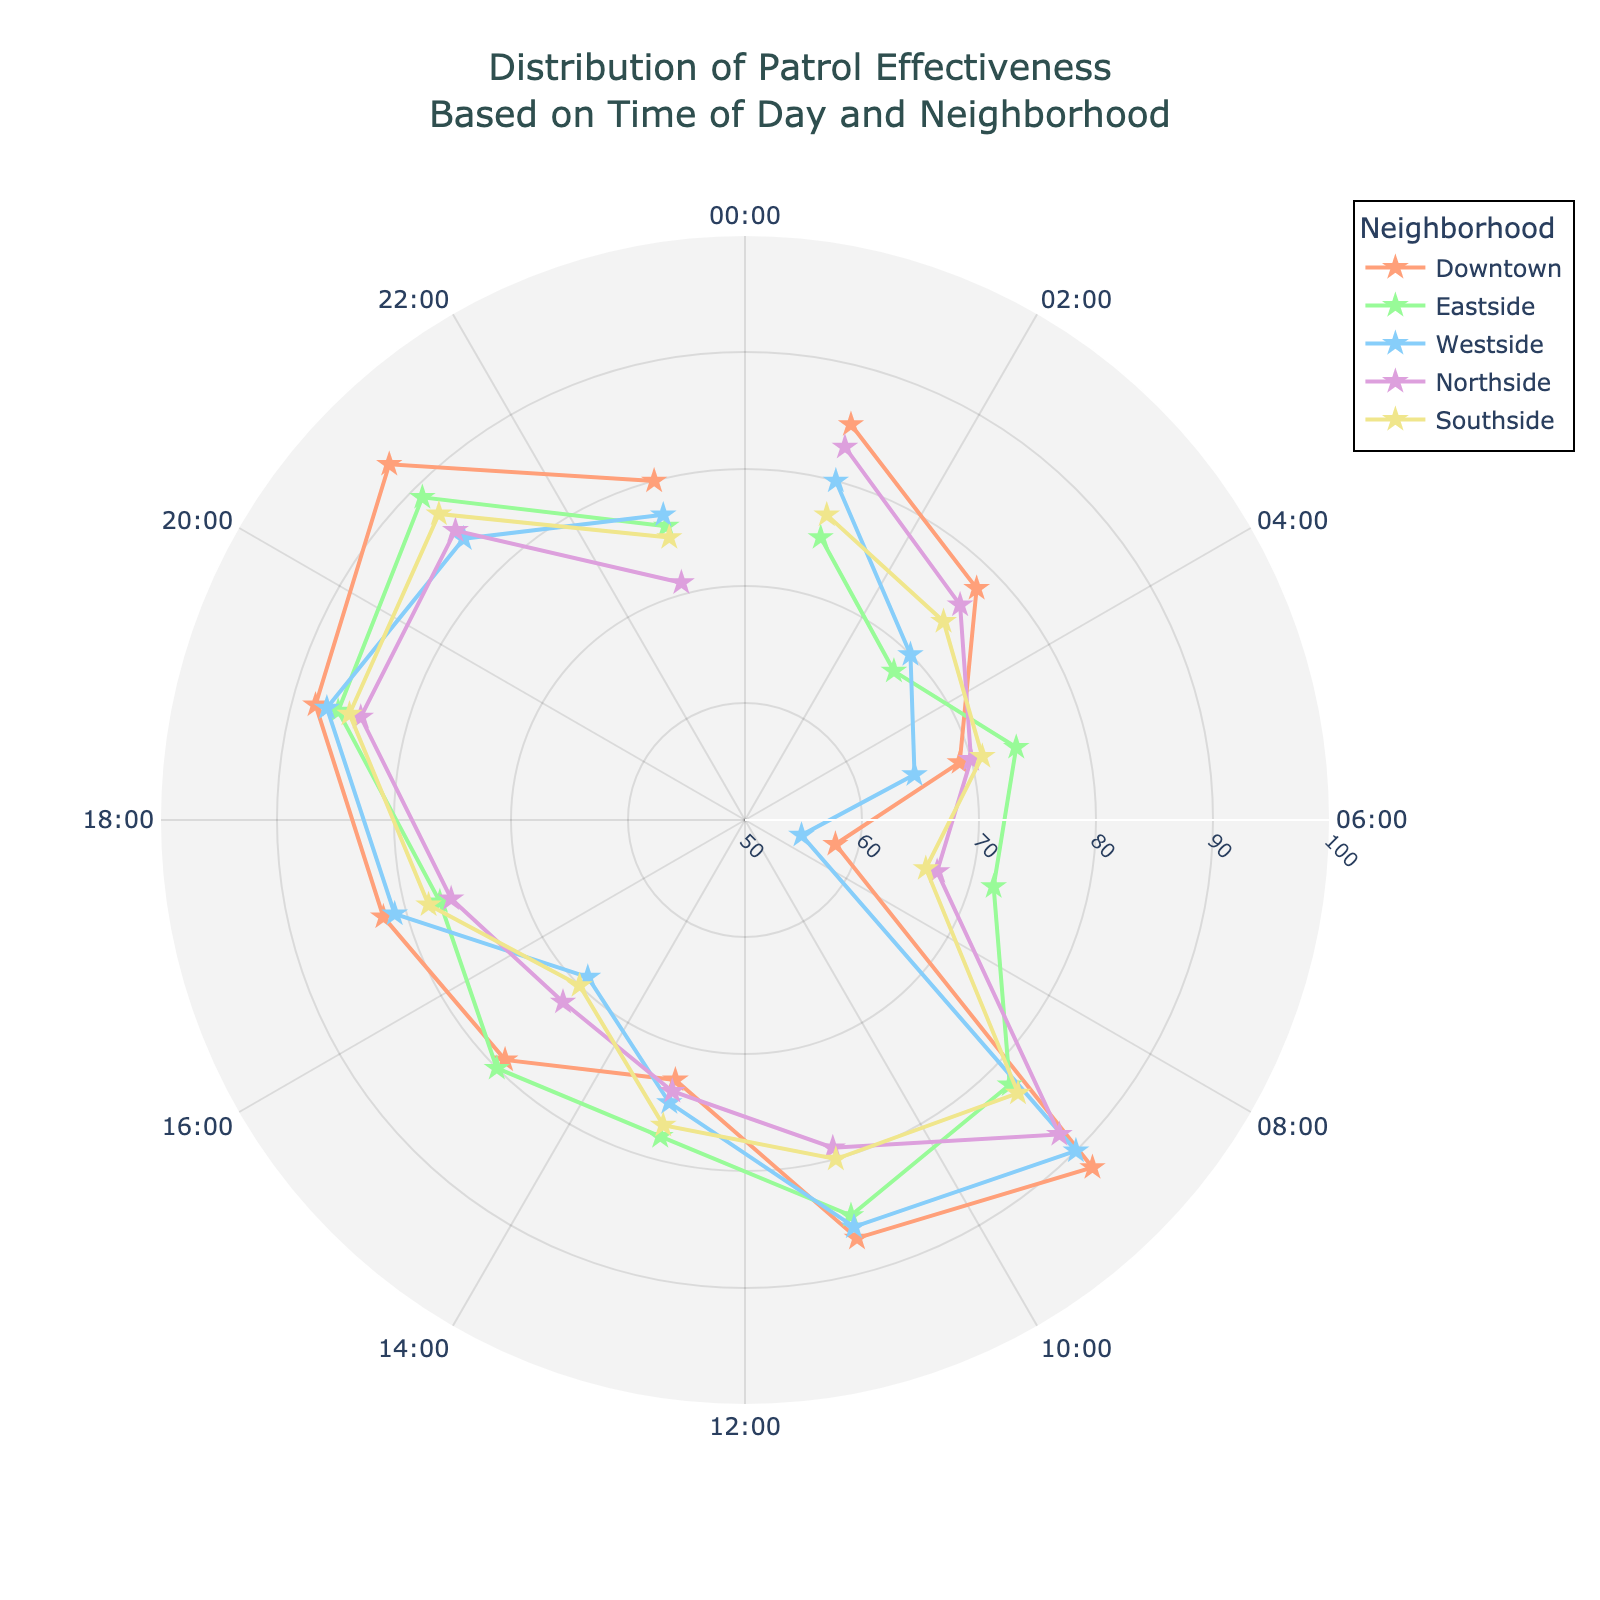How many neighborhoods are shown in the figure? The figure legend lists each neighborhood's name, indicating there are five neighborhoods represented.
Answer: 5 What time of day shows the highest patrol effectiveness for Downtown? By examining the Downtown line, the peak point with the highest radial value corresponds to the 21:00 mark on the angular axis.
Answer: 21:00 During which time period does Westside have the lowest patrol effectiveness? By tracing Westside's lowest radial value, we see that this occurs at 07:00 on the angular axis.
Answer: 07:00 Which neighborhood has the highest patrol effectiveness at 09:00? At 09:00 on the angular axis, comparing the radial values of all neighborhoods reveals that Downtown has the highest patrol effectiveness.
Answer: Downtown Compare the patrol effectiveness at 15:00 between Northside and Southside. At the angular mark for 15:00, Northside has a radial value of 72 while Southside’s radial value is 70, indicating Northside has higher effectiveness.
Answer: Northside What is the average patrol effectiveness for Eastside between 1:00 and 5:00? The effectiveness values for Eastside at 1:00, 3:00, and 5:00 are 75, 68, and 74 respectively. Summing these values yields 217, and averaging three points results in 217/3 = 72.33.
Answer: 72.33 Which neighborhood demonstrates a higher variance in patrol effectiveness over the day, Downtown or Westside? By observing the spread of the radial values, Westside has more fluctuation, ranging from 55 to 90, whereas Downtown ranges from 58 to 93, suggesting Westside has higher variance.
Answer: Westside Which time of day sees the lowest patrol effectiveness for all five neighborhoods combined? By evaluating the lowest radial values across all neighborhoods and all times, the 07:00 time mark has the lowest effectiveness values overall.
Answer: 07:00 